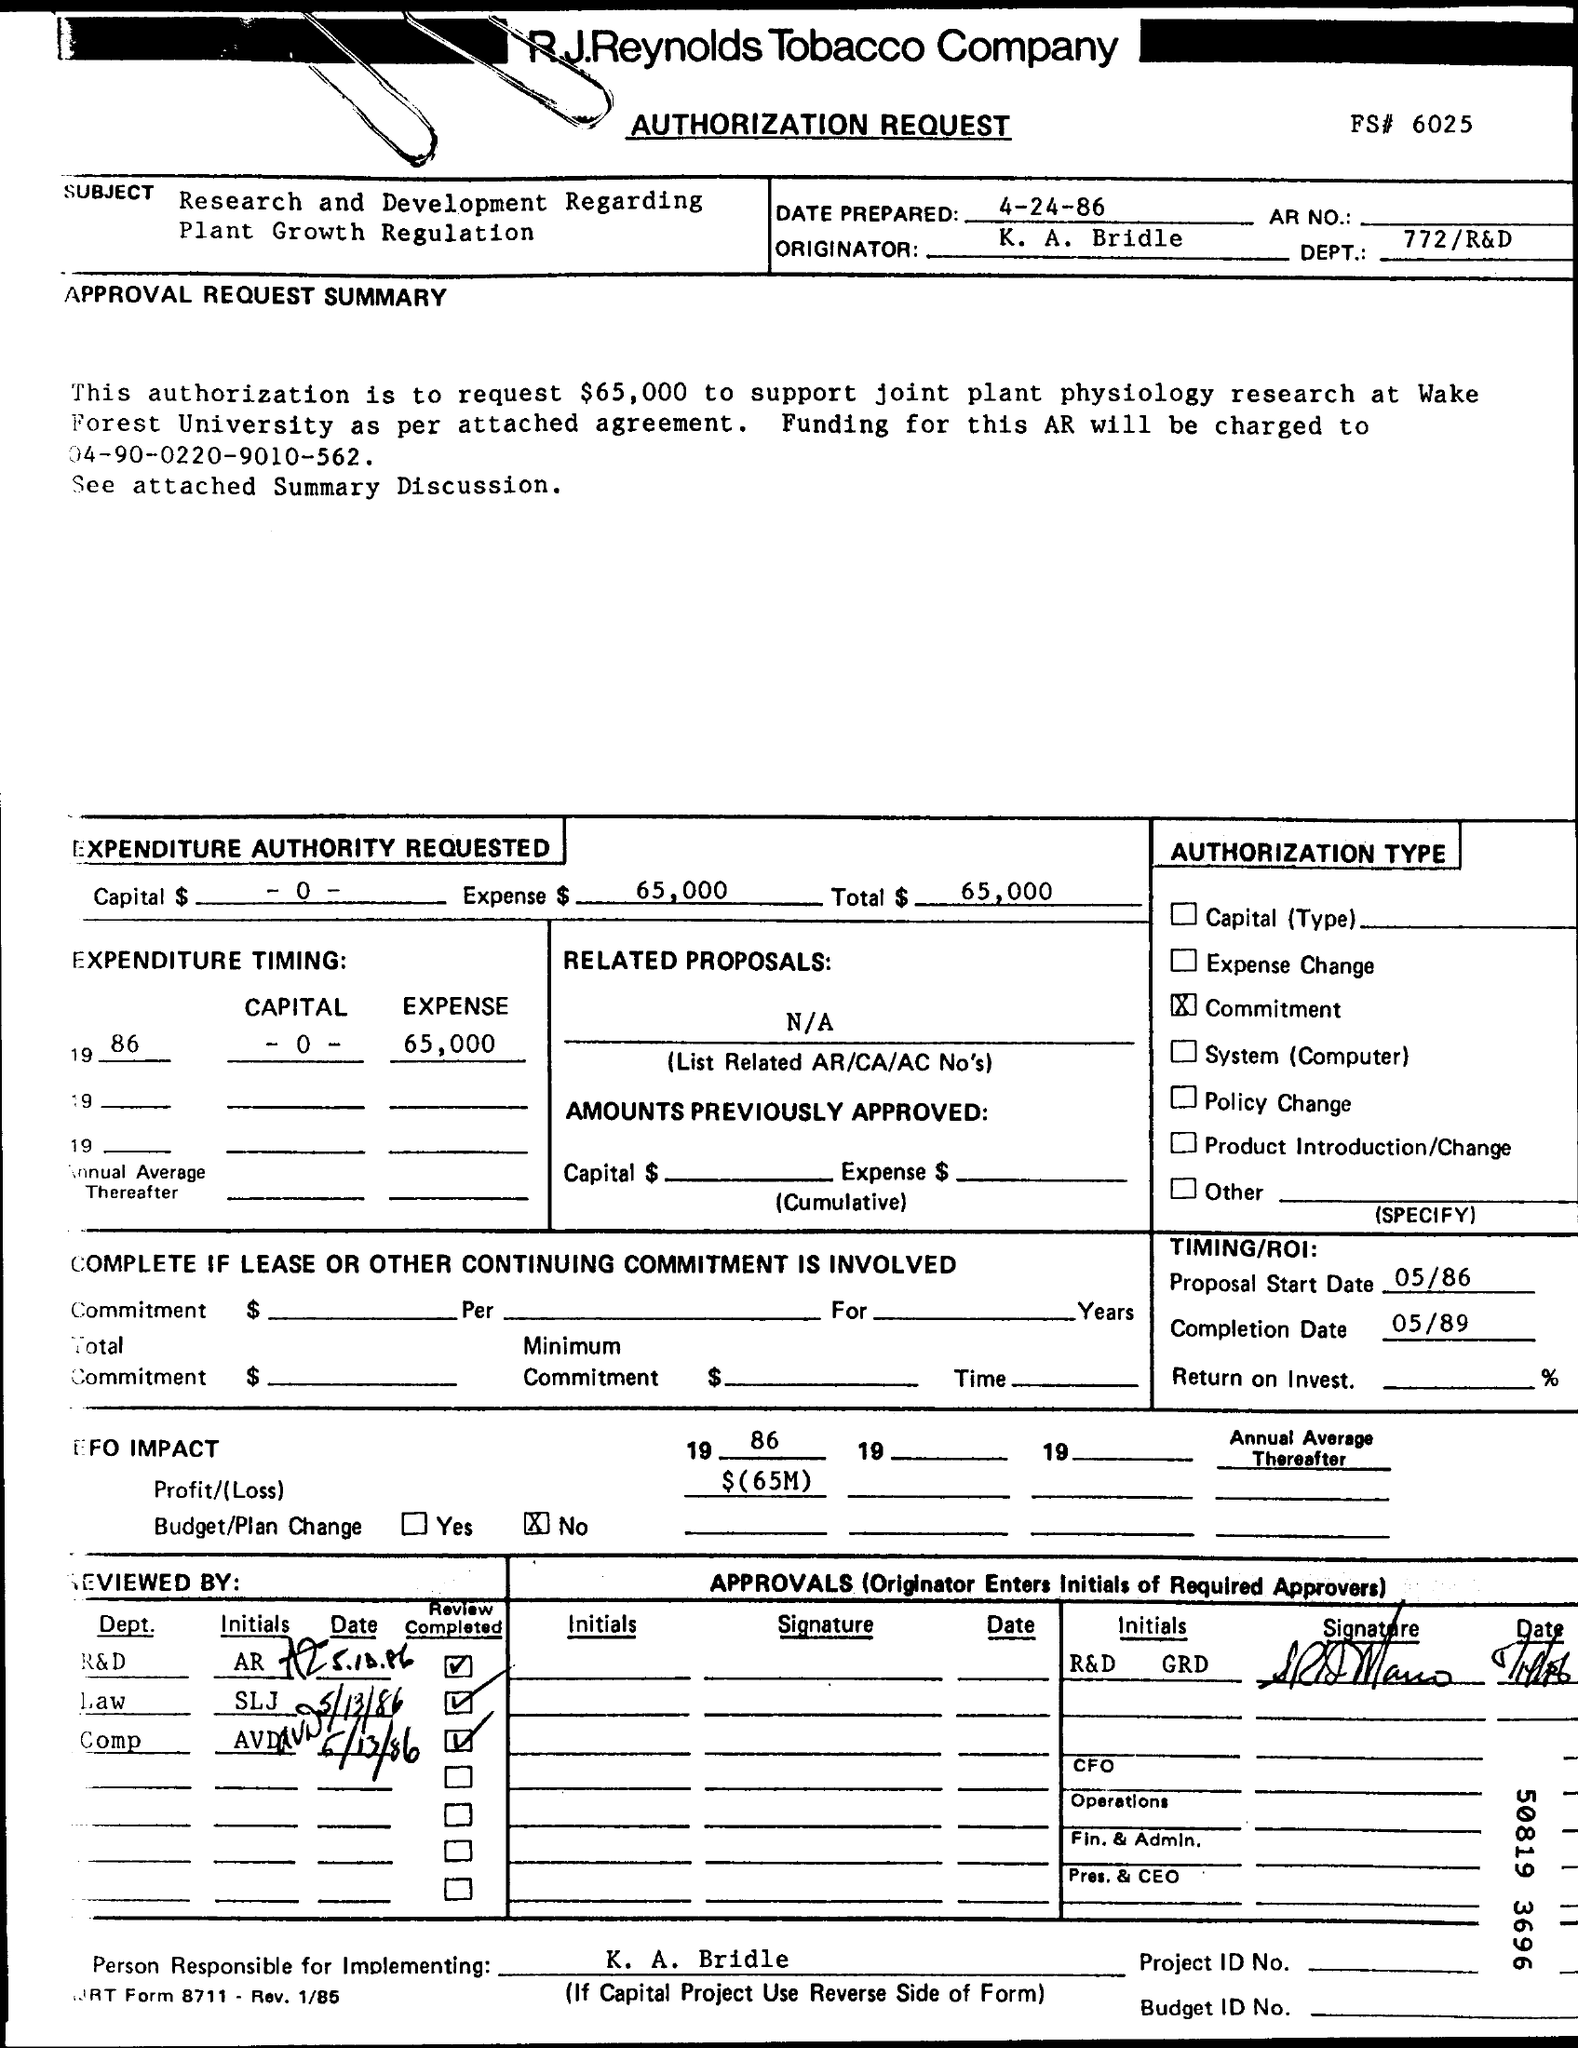Give some essential details in this illustration. On April 24th, 1986, the preparation will have been completed. The DEPT Number is 772/R&D. The R.J.Reynolds Tobacco Company is a company that is inquired about by the speaker. The completion date is May 89. The proposed start date is May 86. 